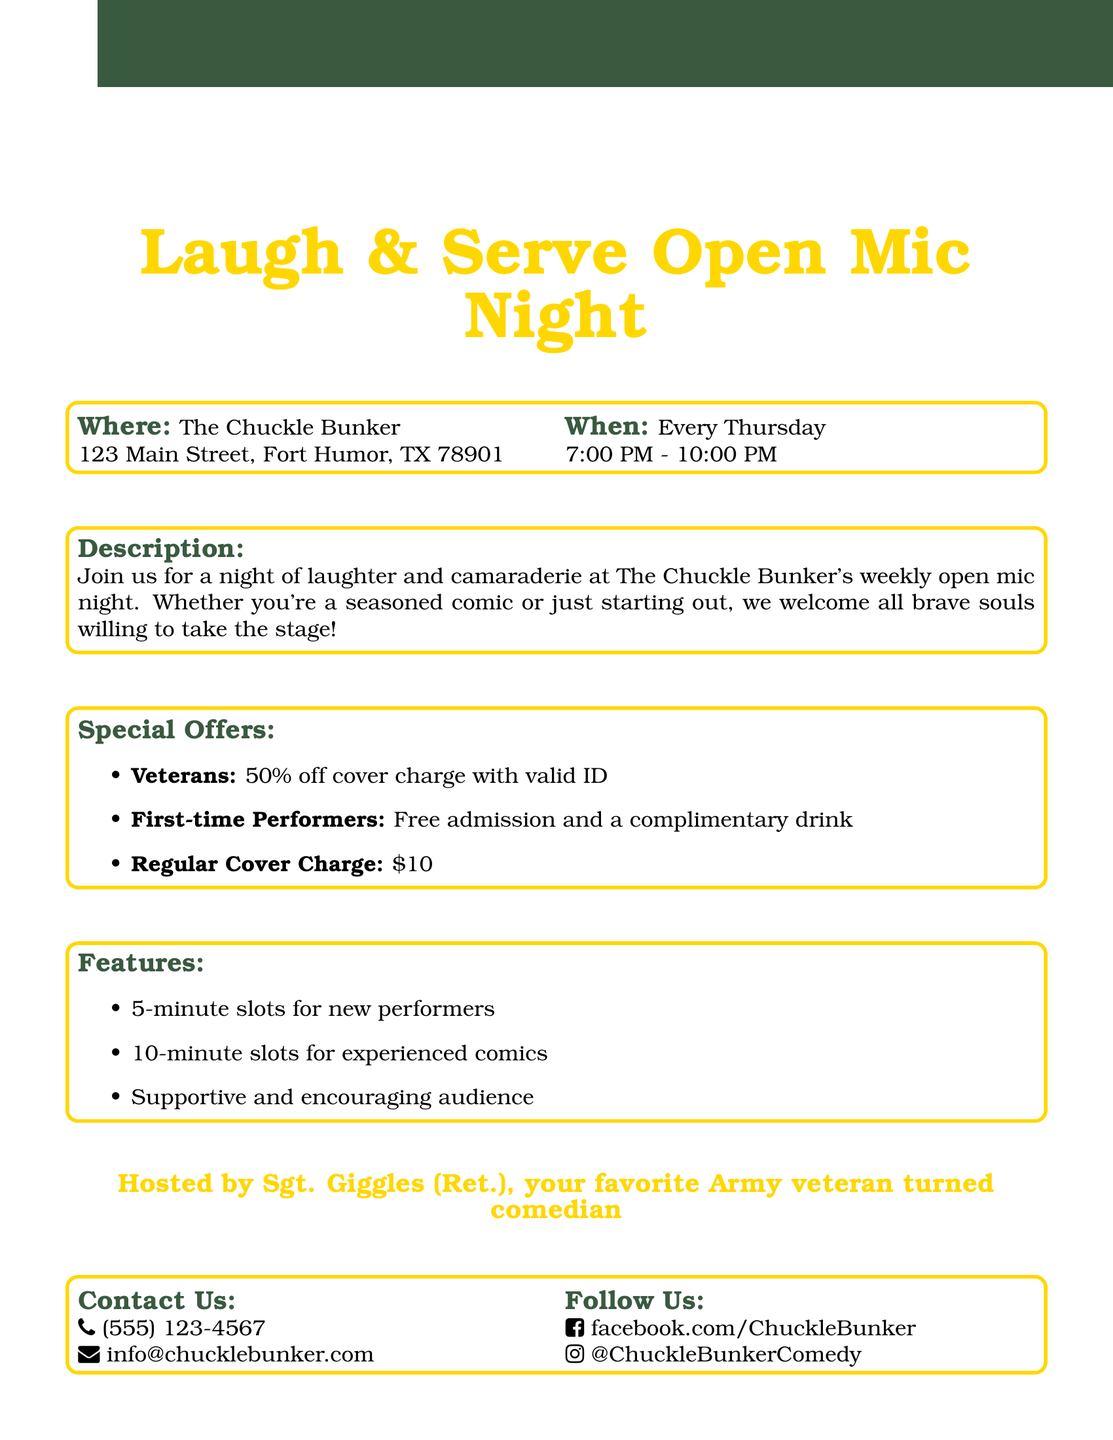What is the name of the event? The event name is prominently highlighted in the document.
Answer: Laugh & Serve Open Mic Night Where is the event held? The venue location is provided within the document.
Answer: The Chuckle Bunker What is the date of the event? The schedule of the event is mentioned clearly in the document.
Answer: Every Thursday What is the time of the event? The specific time for the event is listed in the document.
Answer: 7:00 PM - 10:00 PM What discount is available for veterans? The promotion for veterans is specified in the special offers section.
Answer: 50% off cover charge for all military veterans with valid ID What is the regular cover charge? The regular admission fee is stated in the document under special offers.
Answer: $10 Who is hosting the event? The host's name is mentioned prominently in the document.
Answer: Sgt. Giggles (Ret.) What do first-time performers receive? The benefits for first-time performers are listed in the special offers section.
Answer: Free admission and a complimentary drink How long are the slots for new performers? The duration of performance slots for new comedians is mentioned.
Answer: 5-minute slots How can one contact the event organizers? The contact information is clearly provided in the document.
Answer: (555) 123-4567 